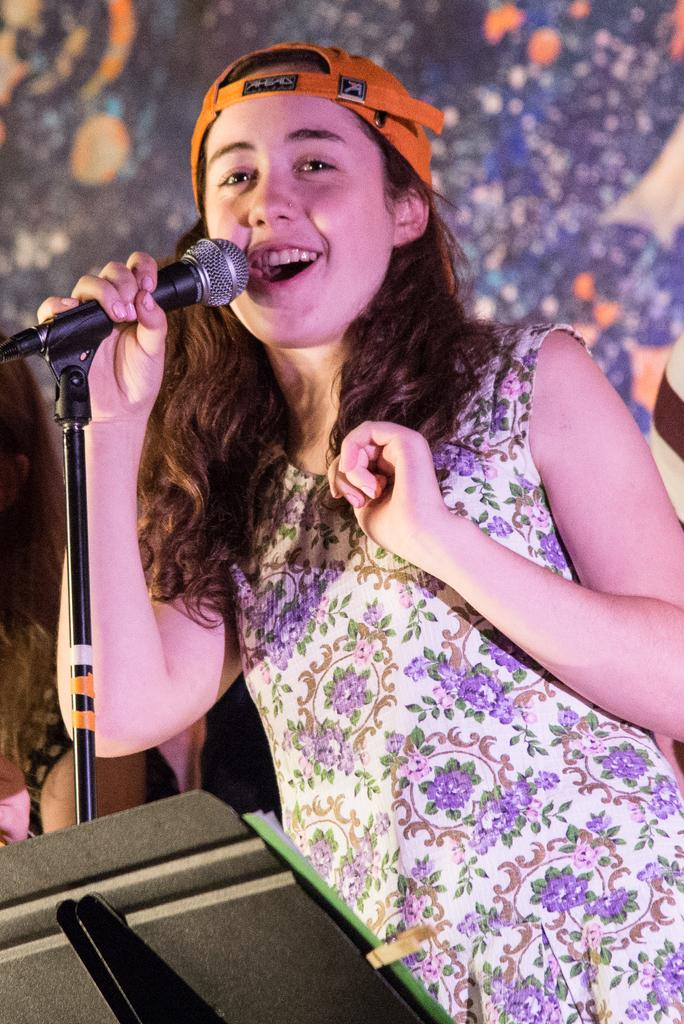Who is the main subject in the image? There is a woman in the image. What is the woman wearing on her head? The woman is wearing an orange cap. What is the woman wearing on her body? The woman is wearing a violet and white dress. What is the woman holding in her hand? The woman is holding a mic. What is the woman doing in the image? The woman is singing a song. What type of fowl can be seen in the image? There is no fowl present in the image; it features a woman singing with a mic. 